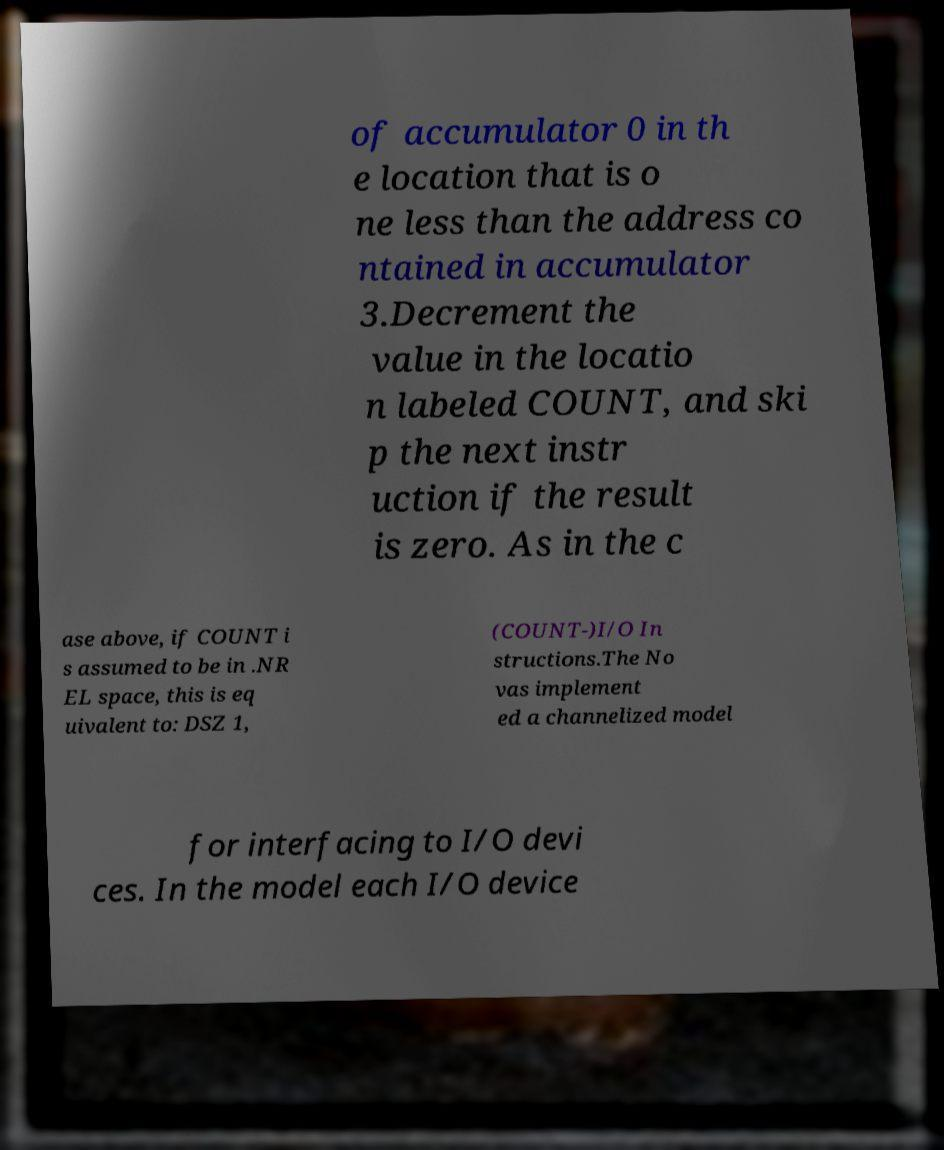There's text embedded in this image that I need extracted. Can you transcribe it verbatim? of accumulator 0 in th e location that is o ne less than the address co ntained in accumulator 3.Decrement the value in the locatio n labeled COUNT, and ski p the next instr uction if the result is zero. As in the c ase above, if COUNT i s assumed to be in .NR EL space, this is eq uivalent to: DSZ 1, (COUNT-)I/O In structions.The No vas implement ed a channelized model for interfacing to I/O devi ces. In the model each I/O device 